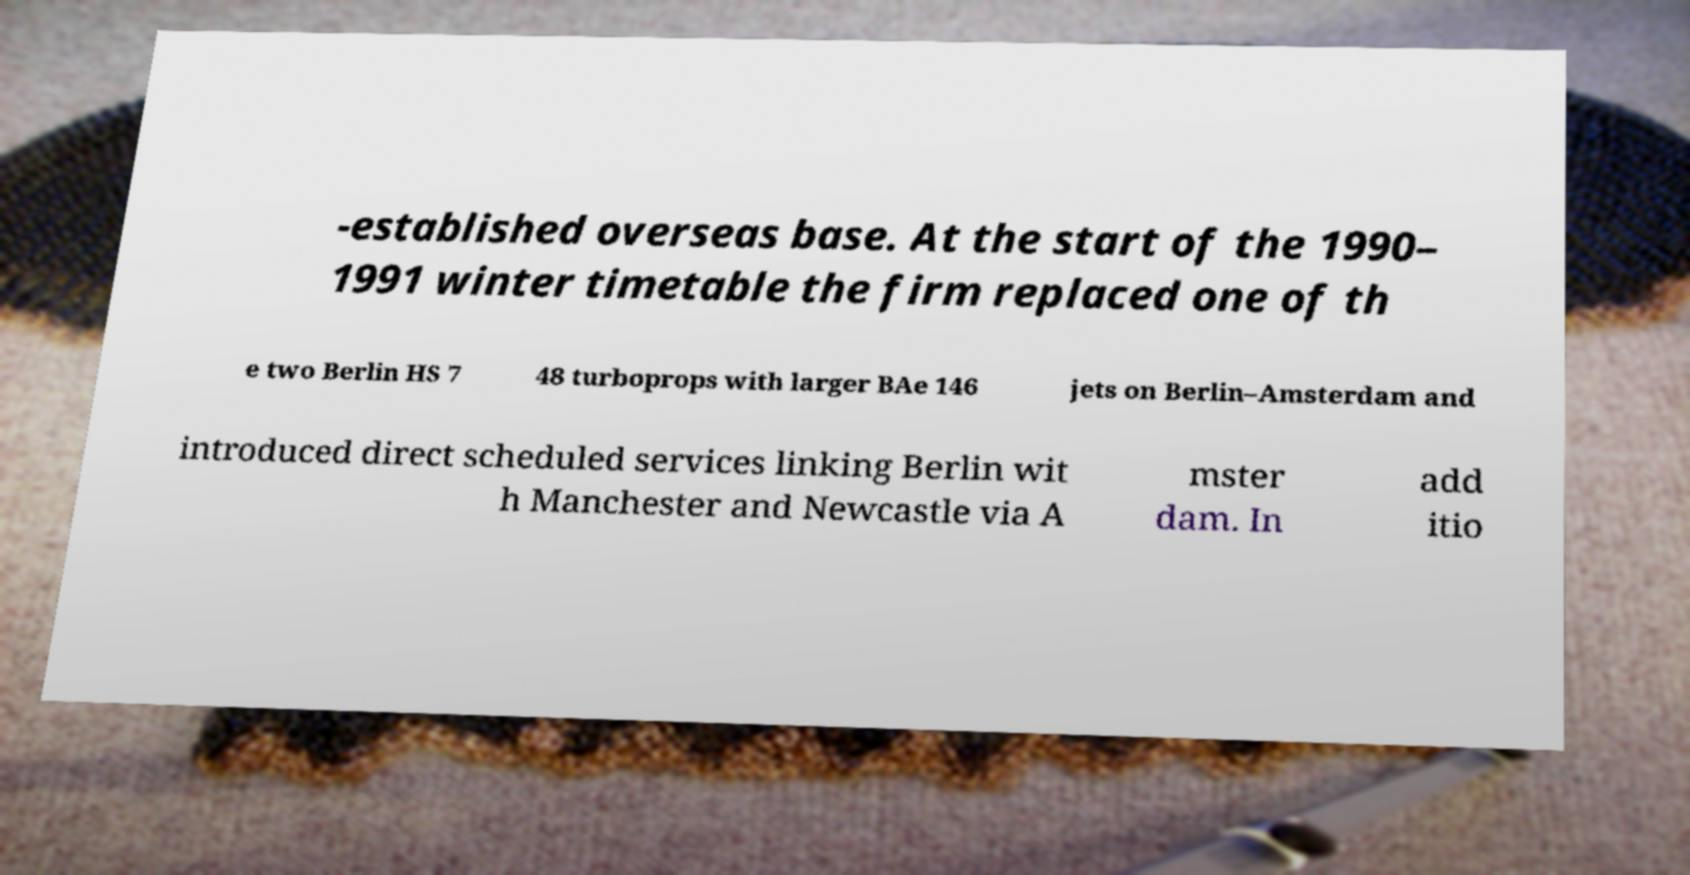Could you extract and type out the text from this image? -established overseas base. At the start of the 1990– 1991 winter timetable the firm replaced one of th e two Berlin HS 7 48 turboprops with larger BAe 146 jets on Berlin–Amsterdam and introduced direct scheduled services linking Berlin wit h Manchester and Newcastle via A mster dam. In add itio 